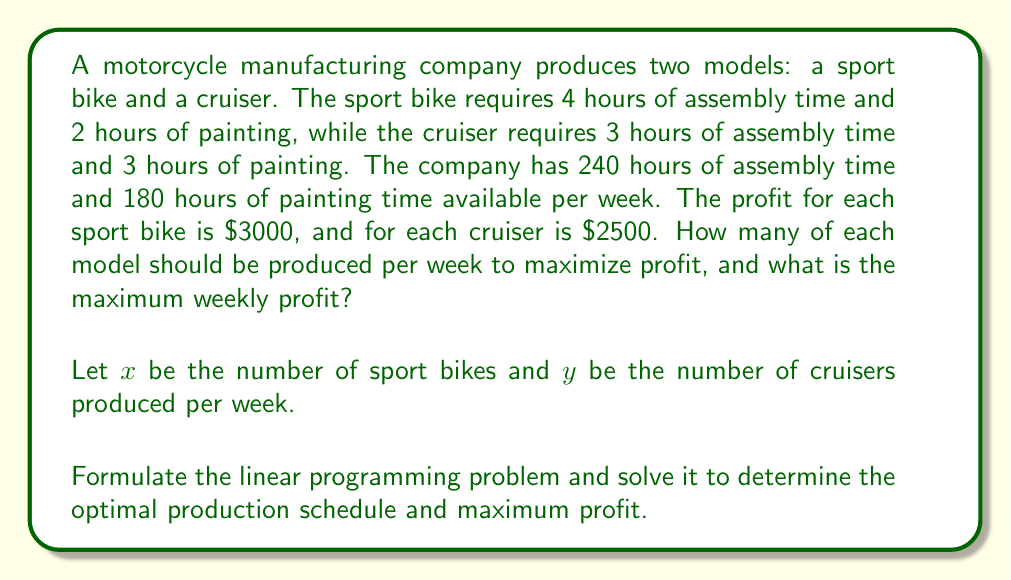Could you help me with this problem? To solve this linear programming problem, we'll follow these steps:

1. Formulate the objective function and constraints:

Objective function (maximize profit):
$$ Z = 3000x + 2500y $$

Constraints:
Assembly time: $4x + 3y \leq 240$
Painting time: $2x + 3y \leq 180$
Non-negativity: $x \geq 0, y \geq 0$

2. Graph the constraints:

[asy]
import geometry;

size(200);
defaultpen(fontsize(10pt));

xaxis("x", 0, 80);
yaxis("y", 0, 80);

draw((0,80)--(60,0), blue);
draw((0,60)--(90,0), red);

label("4x + 3y = 240", (30,40), blue);
label("2x + 3y = 180", (45,30), red);

dot((45,20));
label("(45, 20)", (47,22), E);

dot((0,60));
label("(0, 60)", (2,62), E);

dot((60,0));
label("(60, 0)", (62,2), S);
[/asy]

3. Identify the feasible region and corner points:
The feasible region is bounded by the two constraint lines and the x and y axes.
Corner points: (0,0), (0,60), (45,20), (60,0)

4. Evaluate the objective function at each corner point:
(0,0): Z = 0
(0,60): Z = 150,000
(45,20): Z = 185,000
(60,0): Z = 180,000

5. Determine the optimal solution:
The maximum profit occurs at the point (45,20), which means producing 45 sport bikes and 20 cruisers per week.

6. Calculate the maximum weekly profit:
$$ Z = 3000(45) + 2500(20) = 135,000 + 50,000 = 185,000 $$
Answer: The optimal production schedule is to produce 45 sport bikes and 20 cruisers per week, resulting in a maximum weekly profit of $185,000. 